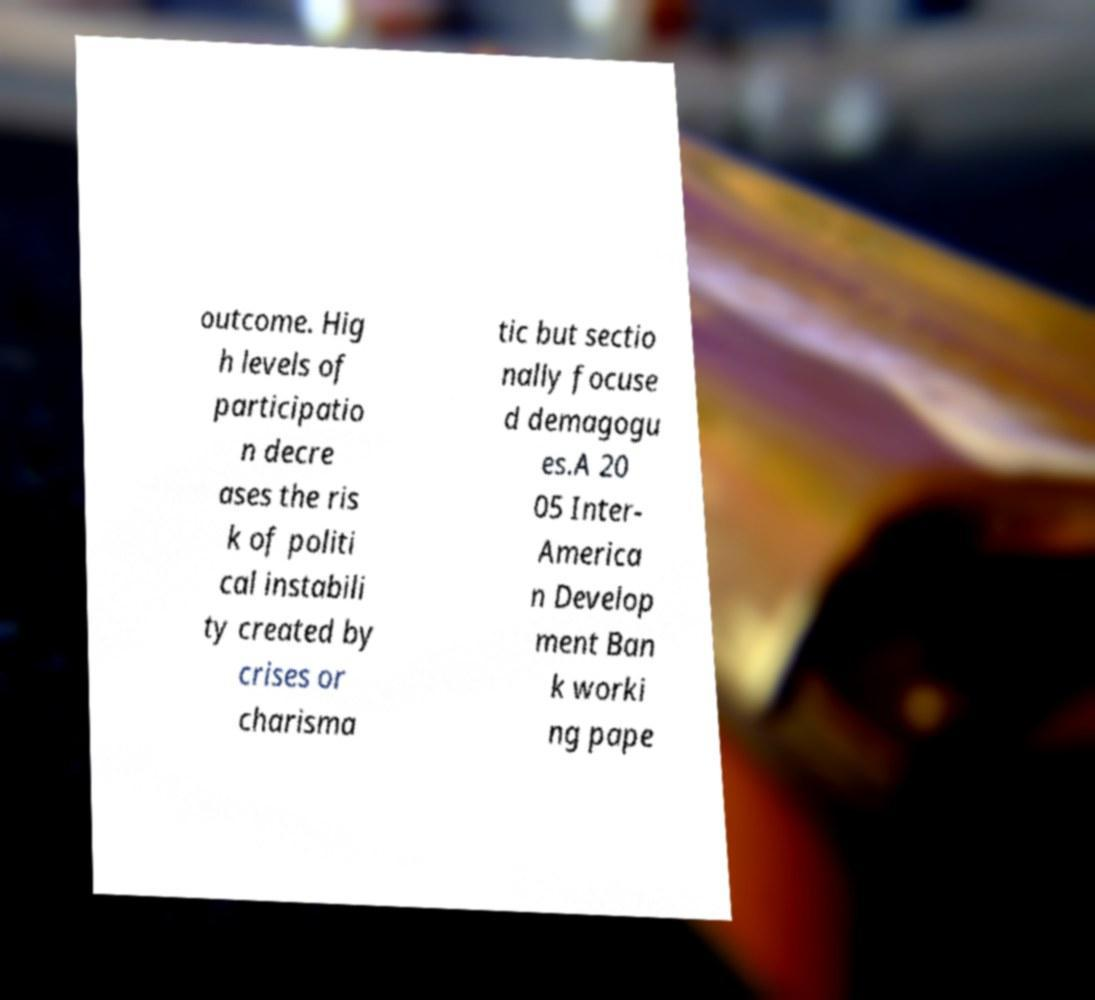Please read and relay the text visible in this image. What does it say? outcome. Hig h levels of participatio n decre ases the ris k of politi cal instabili ty created by crises or charisma tic but sectio nally focuse d demagogu es.A 20 05 Inter- America n Develop ment Ban k worki ng pape 